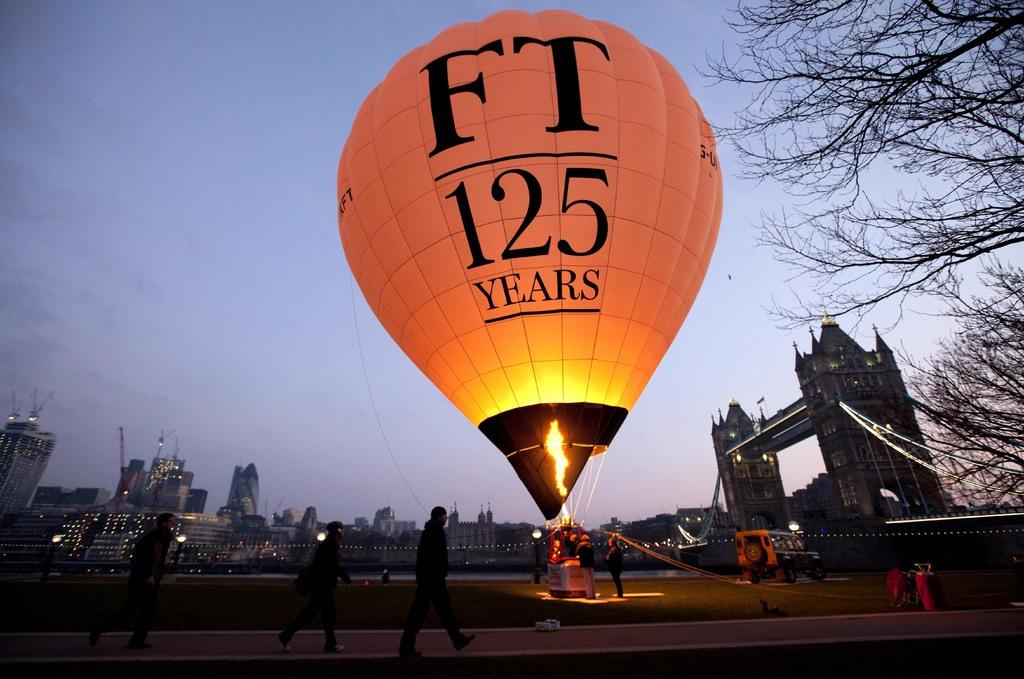<image>
Provide a brief description of the given image. A hot air balloon with FT 125 Years written on it. 